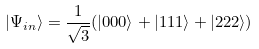Convert formula to latex. <formula><loc_0><loc_0><loc_500><loc_500>| \Psi _ { i n } \rangle = \frac { 1 } { \sqrt { 3 } } ( | 0 0 0 \rangle + | 1 1 1 \rangle + | 2 2 2 \rangle )</formula> 